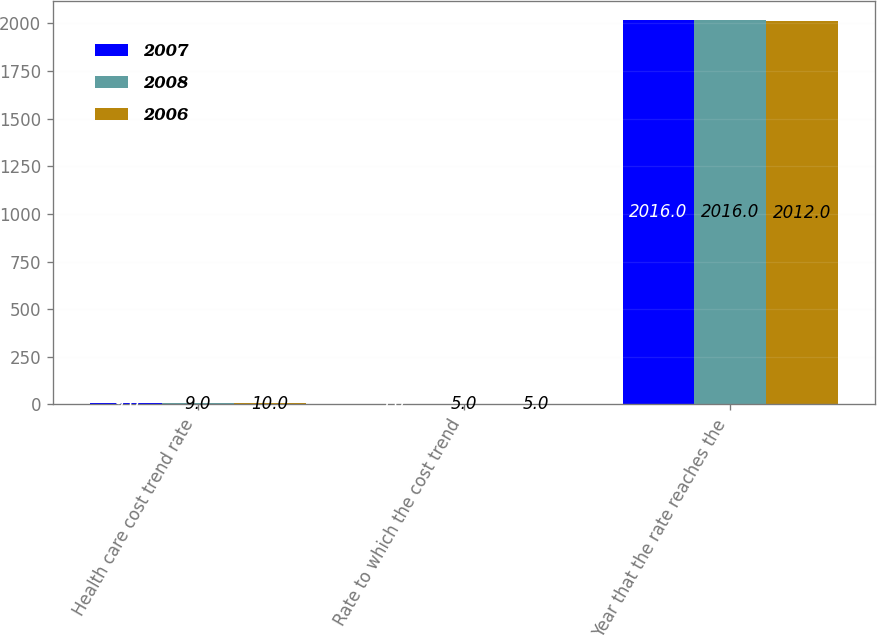<chart> <loc_0><loc_0><loc_500><loc_500><stacked_bar_chart><ecel><fcel>Health care cost trend rate<fcel>Rate to which the cost trend<fcel>Year that the rate reaches the<nl><fcel>2007<fcel>9<fcel>5<fcel>2016<nl><fcel>2008<fcel>9<fcel>5<fcel>2016<nl><fcel>2006<fcel>10<fcel>5<fcel>2012<nl></chart> 